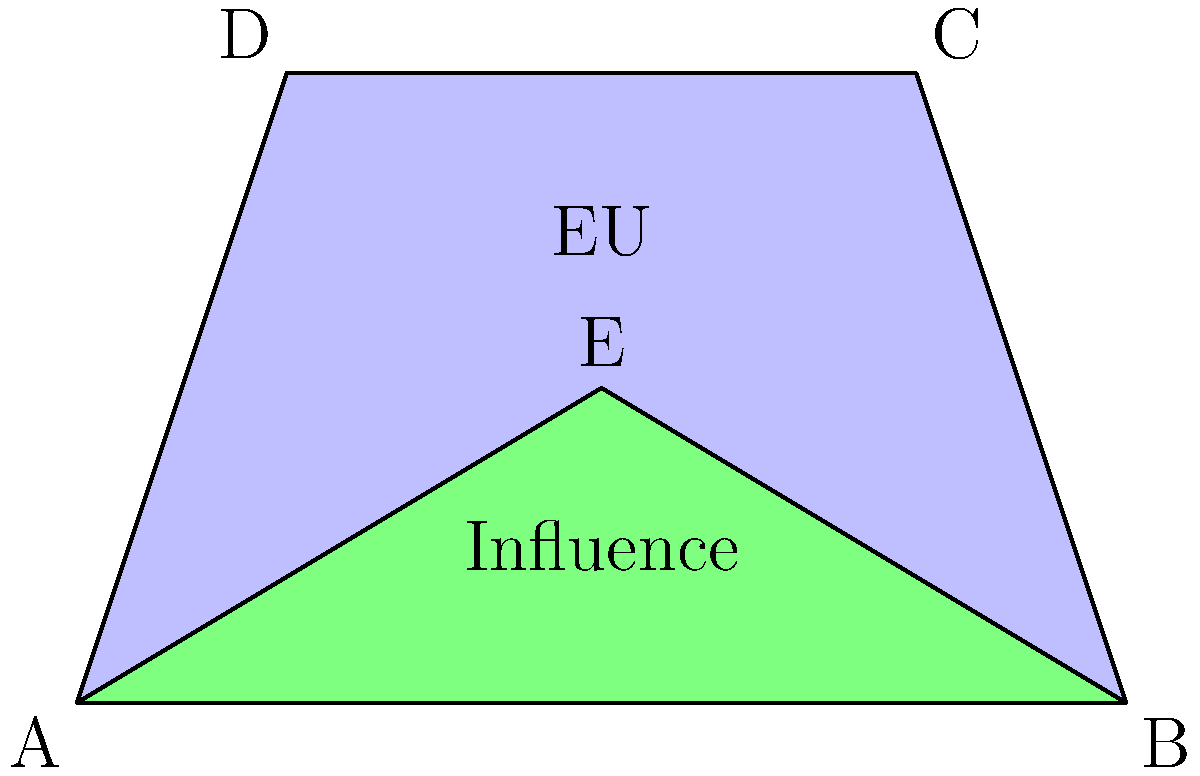A simplified map of Europe is represented by a trapezoid ABCD, where the EU's core area is depicted by the triangle ABE within it. If AB = 10 units, DE = 6 units, and the height of the trapezoid is 6 units, calculate the ratio of the EU's core area of influence to the total area of Europe. How might this ratio impact discussions on EU integration? Let's approach this step-by-step:

1) First, we need to calculate the area of the trapezoid ABCD (total Europe):
   Area of trapezoid = $\frac{1}{2}(AB + DE) \times height$
   $A_{ABCD} = \frac{1}{2}(10 + 6) \times 6 = 48$ square units

2) Now, we need to find the area of triangle ABE (EU's core area):
   To do this, we need the height of the triangle. We can see that it's half the height of the trapezoid.
   Height of triangle ABE = 3 units
   Area of triangle = $\frac{1}{2} \times base \times height$
   $A_{ABE} = \frac{1}{2} \times 10 \times 3 = 15$ square units

3) The ratio of EU's core area to total Europe area:
   $\frac{A_{ABE}}{A_{ABCD}} = \frac{15}{48} = \frac{5}{16} = 0.3125$

4) This means the EU's core area of influence is about 31.25% of the total area of Europe.

5) Impact on EU integration discussions:
   This ratio could spark debates about the EU's reach and influence. It might raise questions about:
   - Whether the EU should aim to expand its core area of influence
   - How to balance the interests of core and peripheral regions
   - Strategies for deeper integration within the core vs. broader expansion
   - The challenges of maintaining cohesion across diverse areas
Answer: $\frac{5}{16}$ or 0.3125 or 31.25% 